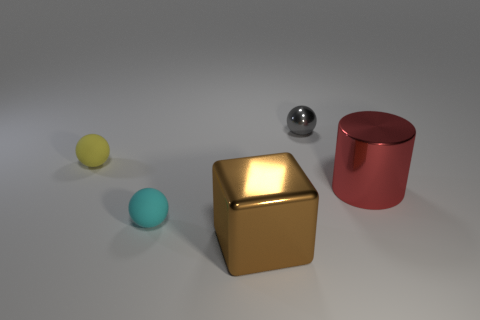Are the tiny yellow sphere left of the big brown object and the tiny cyan ball made of the same material?
Provide a short and direct response. Yes. The shiny object that is the same size as the cylinder is what color?
Your answer should be very brief. Brown. What is the size of the gray thing that is the same material as the brown thing?
Offer a terse response. Small. What number of other things are there of the same size as the metal cube?
Your response must be concise. 1. What material is the tiny object that is left of the cyan rubber ball?
Your answer should be compact. Rubber. There is a thing that is left of the tiny rubber sphere in front of the tiny yellow sphere that is behind the red metallic object; what shape is it?
Offer a very short reply. Sphere. Do the shiny cylinder and the brown metallic cube have the same size?
Ensure brevity in your answer.  Yes. What number of objects are either large purple cubes or spheres that are left of the large brown block?
Your response must be concise. 2. How many objects are either spheres that are in front of the yellow matte object or small things left of the large brown block?
Keep it short and to the point. 2. Are there any metallic objects behind the red metal cylinder?
Provide a short and direct response. Yes. 